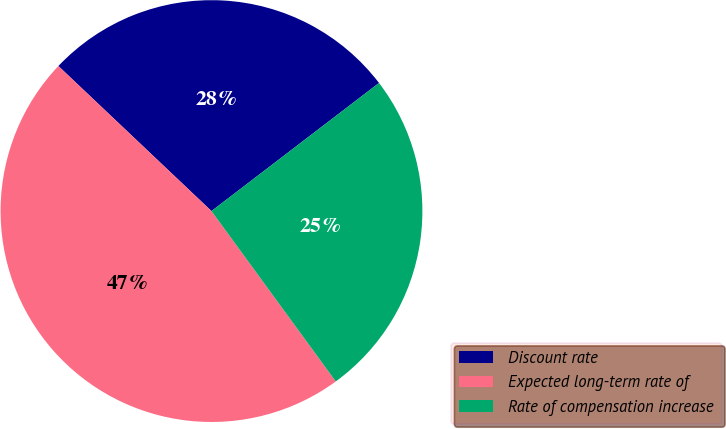Convert chart to OTSL. <chart><loc_0><loc_0><loc_500><loc_500><pie_chart><fcel>Discount rate<fcel>Expected long-term rate of<fcel>Rate of compensation increase<nl><fcel>27.54%<fcel>47.1%<fcel>25.36%<nl></chart> 